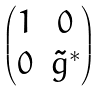<formula> <loc_0><loc_0><loc_500><loc_500>\begin{pmatrix} 1 & 0 \\ 0 & { \tilde { g } } ^ { * } \end{pmatrix}</formula> 